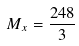<formula> <loc_0><loc_0><loc_500><loc_500>M _ { x } = \frac { 2 4 8 } { 3 }</formula> 